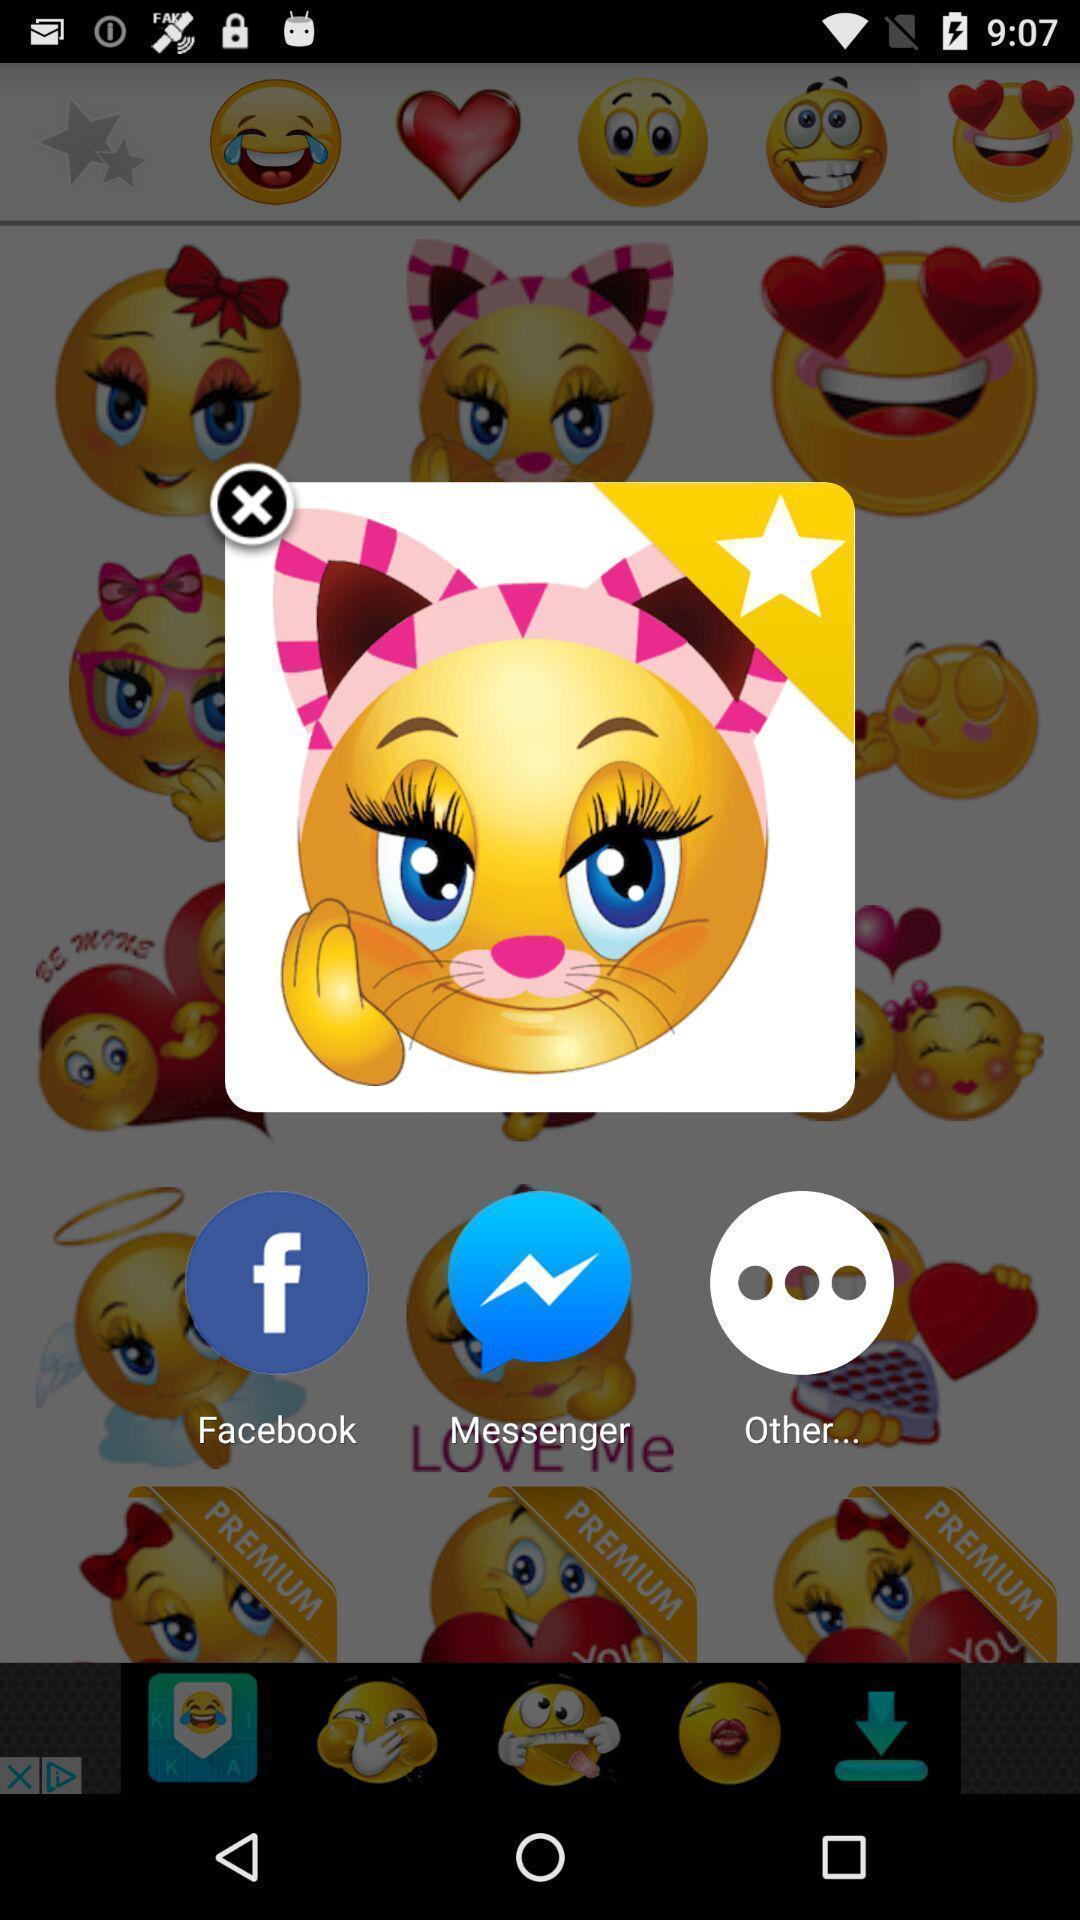Give me a narrative description of this picture. Pop-up showing the emoji with different share options. 